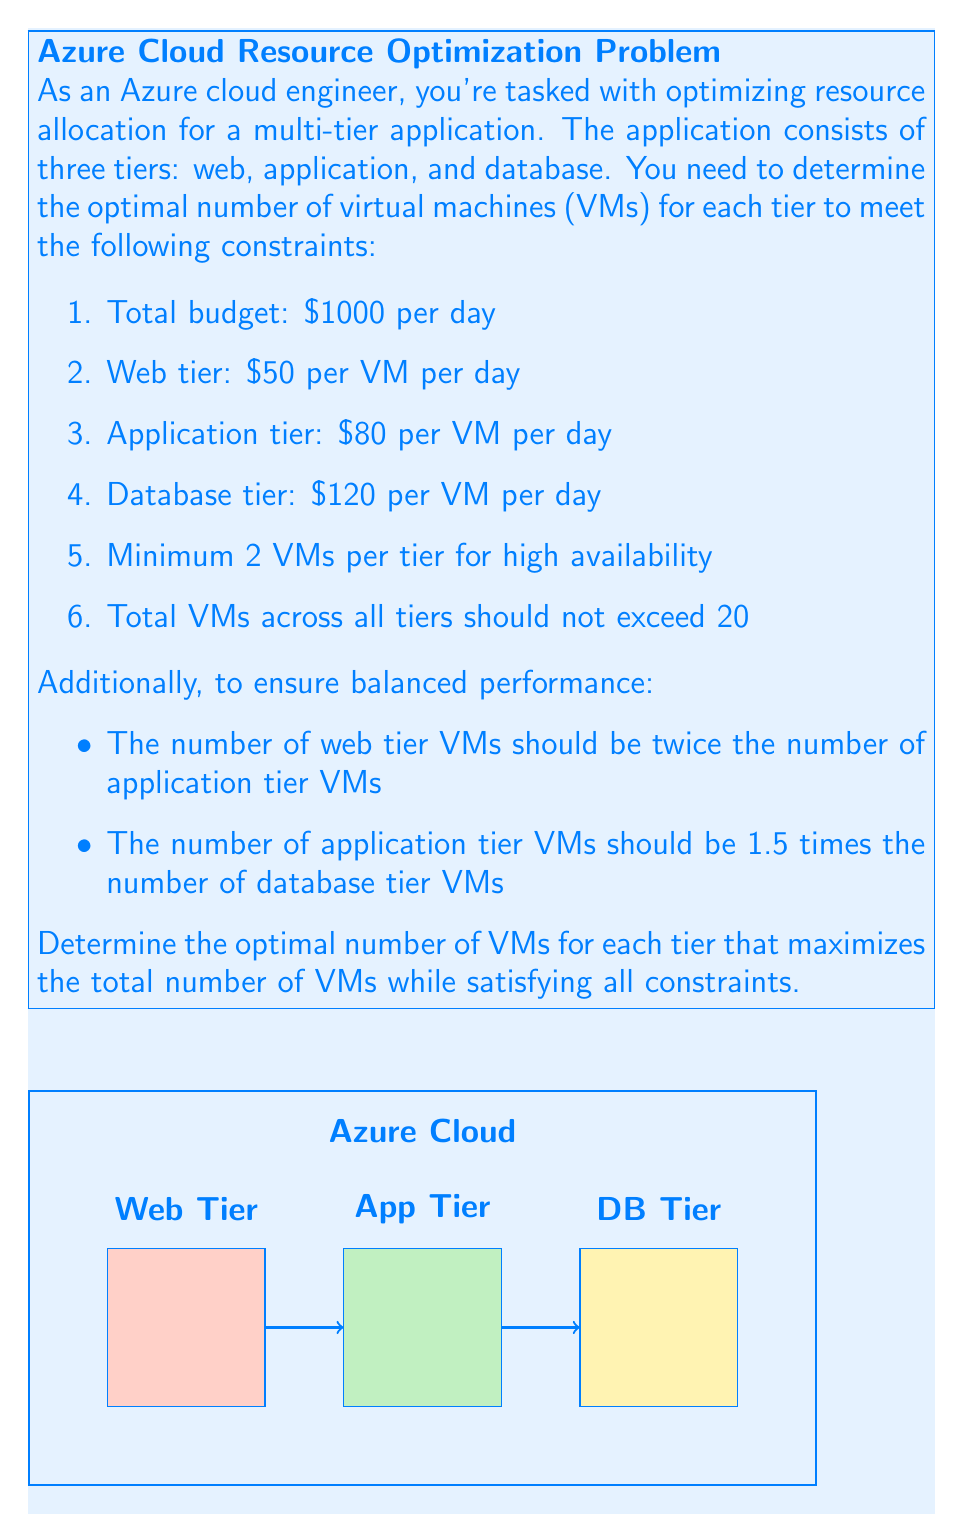Help me with this question. Let's approach this step-by-step using a system of linear equations:

1) Let $x$ be the number of database tier VMs. Then:
   - Application tier VMs = $1.5x$
   - Web tier VMs = $2(1.5x) = 3x$

2) The total number of VMs equation:
   $$x + 1.5x + 3x = 5.5x \leq 20$$

3) The budget constraint equation:
   $$120x + 80(1.5x) + 50(3x) \leq 1000$$
   $$120x + 120x + 150x \leq 1000$$
   $$390x \leq 1000$$

4) Solving the inequalities:
   From (2): $x \leq \frac{20}{5.5} \approx 3.64$
   From (3): $x \leq \frac{1000}{390} \approx 2.56$

5) Given the minimum 2 VMs per tier and that we need to maximize the total, we should use the smaller upper bound: $x = 2.56$

6) Rounding down to satisfy the constraints:
   - Database tier: $x = 2$ VMs
   - Application tier: $1.5x = 1.5(2) = 3$ VMs
   - Web tier: $3x = 3(2) = 6$ VMs

7) Verifying constraints:
   - Total VMs: $2 + 3 + 6 = 11 \leq 20$
   - Budget: $2(120) + 3(80) + 6(50) = 240 + 240 + 300 = 780 \leq 1000$
   - Minimum 2 VMs per tier: Satisfied
   - Ratio constraints: Satisfied

Therefore, the optimal allocation is 2 database VMs, 3 application VMs, and 6 web VMs.
Answer: Database: 2 VMs, Application: 3 VMs, Web: 6 VMs 